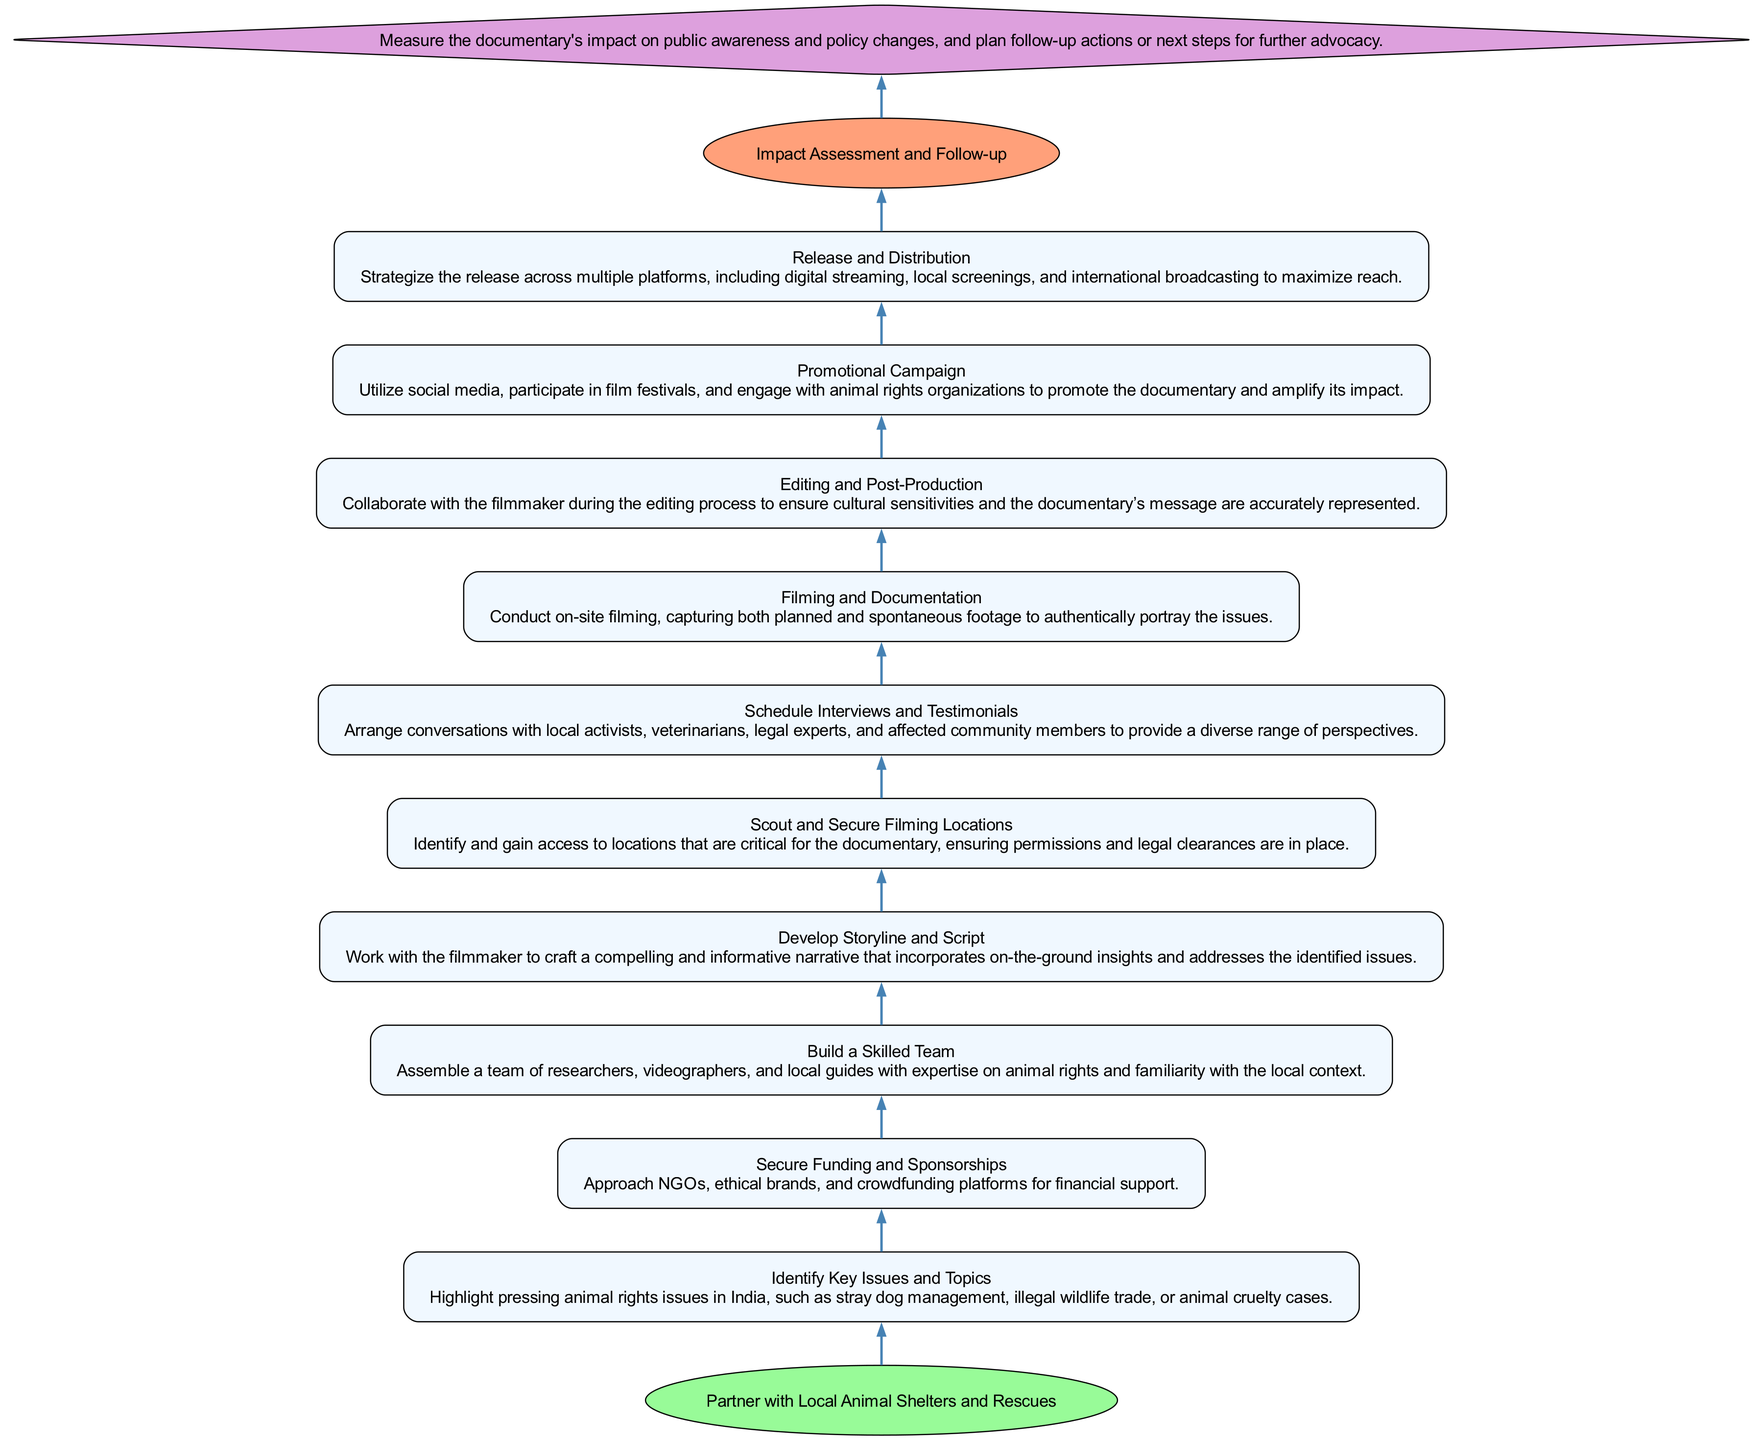What is the bottom node in this flowchart? The bottom node is indicated as the starting point of the flowchart. According to the provided data, it represents the foundational action necessary for the documentary collaboration.
Answer: Partner with Local Animal Shelters and Rescues How many nodes are there in total? Count all the unique nodes listed in the flowchart, which includes the bottom node, the top node, the impact assessment node, and each node representing the different steps in the process. There are 12 nodes in total.
Answer: 12 What comes after "Build a Skilled Team"? The flowchart illustrates a sequence where each element is connected in the order of execution. To find the answer, look for the node that directly follows "Build a Skilled Team."
Answer: Develop Storyline and Script Which node is connected directly to "Impact Assessment and Follow-up"? In the flowchart, the last action is connected directly to the impact assessment node. This connection indicates the final evaluation step in the documentary's process.
Answer: Top How many connections does the node "Editing and Post-Production" have? By examining the flowchart, we can count the number of edges linked to its node. Since each node is part of a sequence, the node "Editing and Post-Production" has one outgoing connection to "Promotional Campaign" and one incoming from "Filming and Documentation."
Answer: 2 What is the relationship between "Secure Funding and Sponsorships" and "Identify Key Issues and Topics"? The relationship is sequential in the flow of the flowchart. "Secure Funding and Sponsorships" comes after "Identify Key Issues and Topics," meaning that the identification of key issues must happen before funding is pursued.
Answer: Sequential relationship Which node serves as the conclusion of the flowchart? The conclusion node is defined in the flowchart as the ultimate outcome of the entire process, indicating the final step. It ties together the entire flow of actions taken in the documentary process.
Answer: Impact Assessment and Follow-up What is the first step after the bottom node? The flowchart outlines a clear path starting from the bottom node. The first action that follows is listed directly above the bottom node in the diagram.
Answer: Identify Key Issues and Topics How many nodes are there between the "Build a Skilled Team" and "Promotional Campaign" nodes? To find the number of nodes in between, we can count the nodes appearing between these two specific steps, moving upwards through the flowchart. There are three nodes connecting them.
Answer: 3 